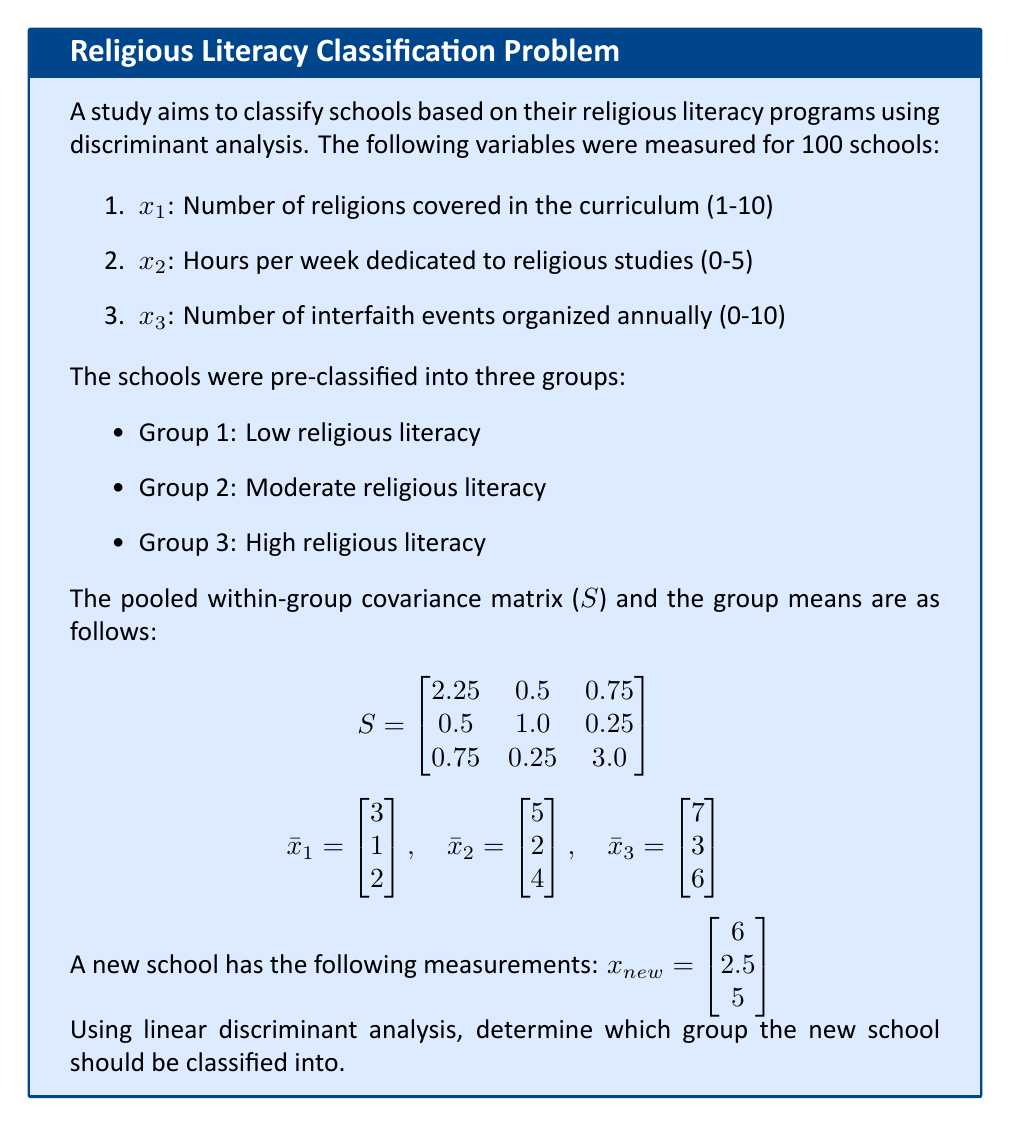Can you solve this math problem? To classify the new school using linear discriminant analysis, we need to follow these steps:

1. Calculate the inverse of the pooled within-group covariance matrix $S^{-1}$:

$$S^{-1} = \begin{bmatrix}
0.4898 & -0.2041 & -0.0816 \\
-0.2041 & 1.1224 & -0.0408 \\
-0.0816 & -0.0408 & 0.3673
\end{bmatrix}$$

2. Calculate the linear discriminant functions for each group:
$d_i(x) = x^T S^{-1} \bar{x}_i - \frac{1}{2} \bar{x}_i^T S^{-1} \bar{x}_i$

For Group 1:
$d_1(x) = 1.4694x_1 + 0.7143x_2 + 0.5714x_3 - 5.0510$

For Group 2:
$d_2(x) = 2.4490x_1 + 1.4286x_2 + 1.1429x_3 - 13.8776$

For Group 3:
$d_3(x) = 3.4286x_1 + 2.1429x_2 + 1.7143x_3 - 26.5306$

3. Evaluate the discriminant functions for the new school:
$x_{new} = \begin{bmatrix} 6 \\ 2.5 \\ 5 \end{bmatrix}$

$d_1(x_{new}) = 1.4694(6) + 0.7143(2.5) + 0.5714(5) - 5.0510 = 10.7347$

$d_2(x_{new}) = 2.4490(6) + 1.4286(2.5) + 1.1429(5) - 13.8776 = 14.2857$

$d_3(x_{new}) = 3.4286(6) + 2.1429(2.5) + 1.7143(5) - 26.5306 = 15.0001$

4. Classify the new school into the group with the highest discriminant function value.

Since $d_3(x_{new})$ has the highest value, the new school should be classified into Group 3: High religious literacy.
Answer: Group 3: High religious literacy 